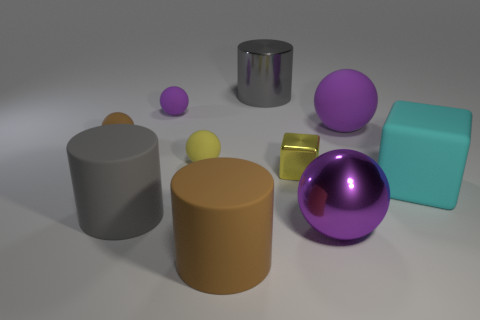There is a gray cylinder that is made of the same material as the large block; what is its size?
Provide a succinct answer. Large. What is the size of the brown rubber thing that is in front of the purple metallic object?
Your answer should be very brief. Large. What number of objects are the same size as the metal block?
Offer a terse response. 3. There is a rubber object that is the same color as the big metal cylinder; what is its size?
Offer a very short reply. Large. Are there any other cylinders that have the same color as the shiny cylinder?
Your answer should be very brief. Yes. There is a block that is the same size as the brown rubber ball; what color is it?
Give a very brief answer. Yellow. Is the color of the metal cube the same as the small rubber object that is in front of the tiny brown matte thing?
Your answer should be very brief. Yes. What color is the big metal cylinder?
Provide a short and direct response. Gray. What is the material of the large gray cylinder in front of the small yellow metal cube?
Your answer should be very brief. Rubber. There is a purple shiny object that is the same shape as the small yellow matte thing; what size is it?
Ensure brevity in your answer.  Large. 